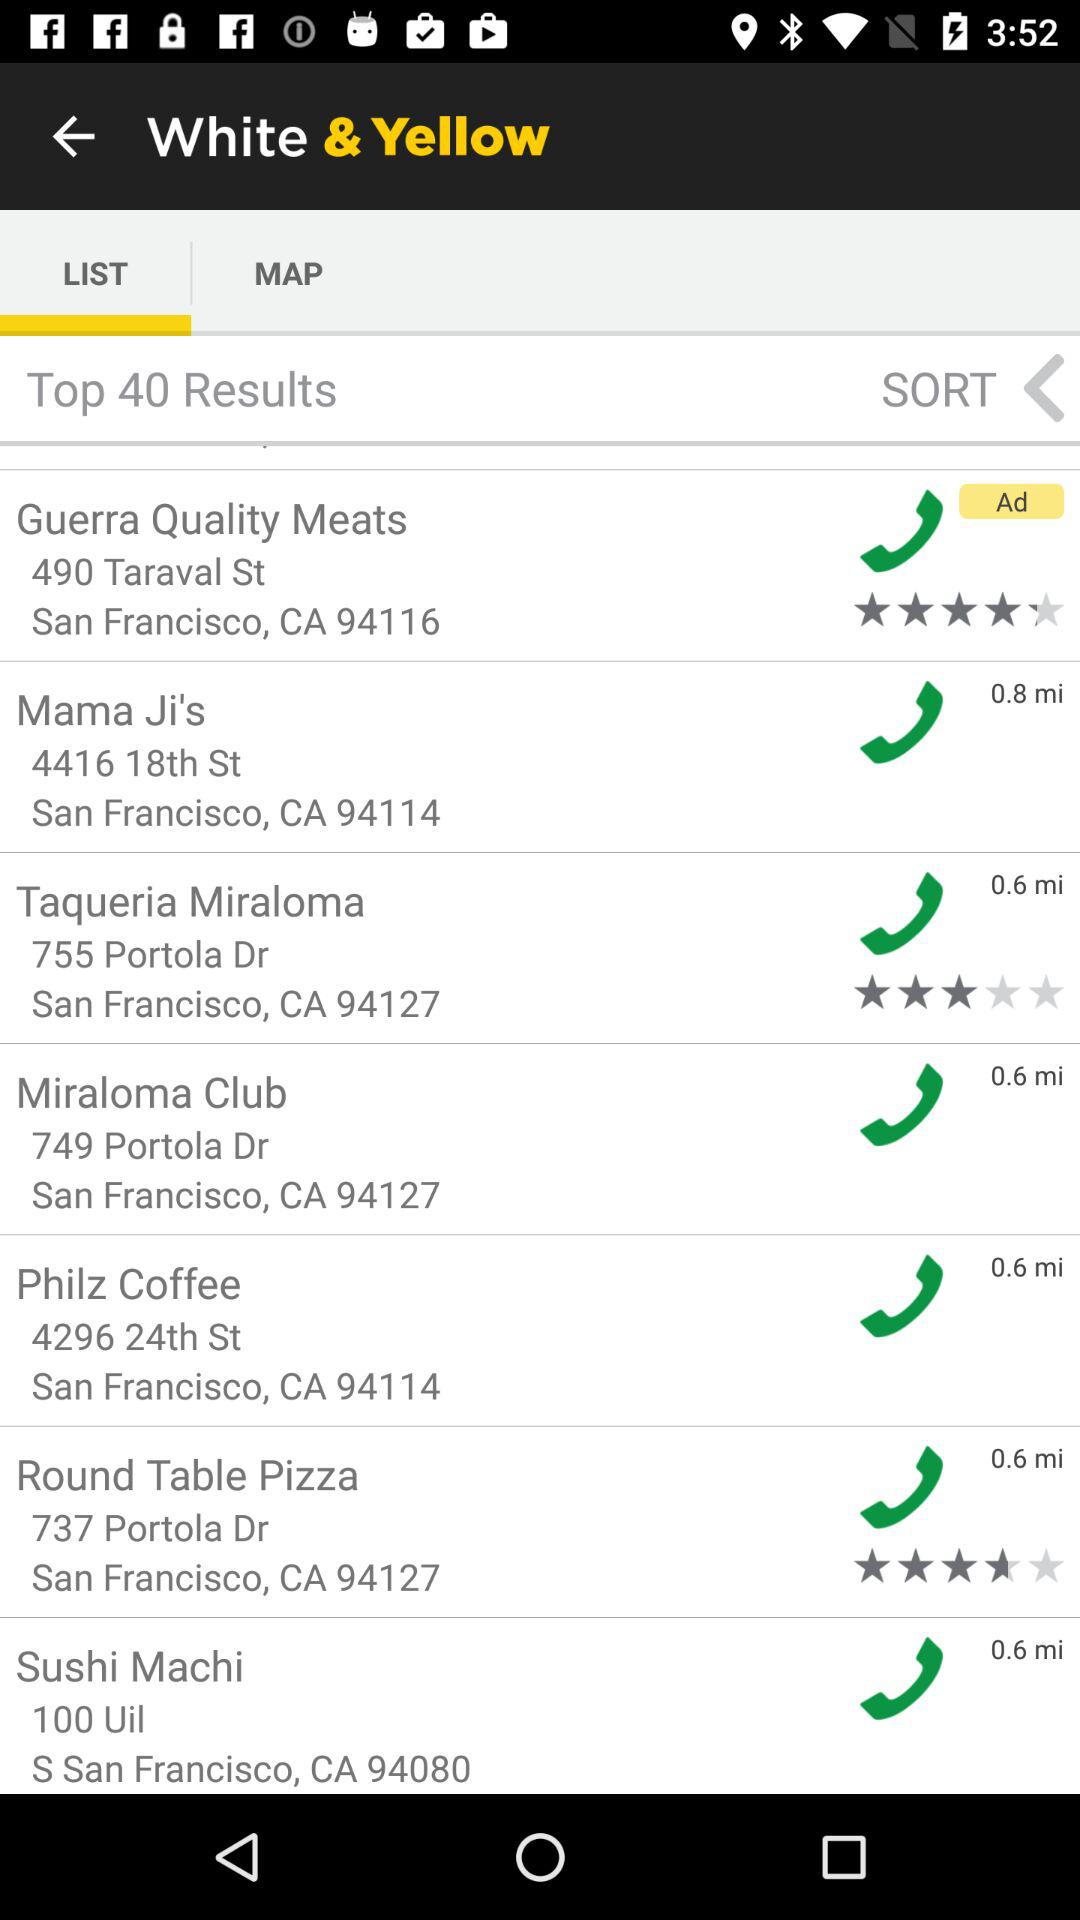What city is mentioned? The mentioned city is San Francisco. 